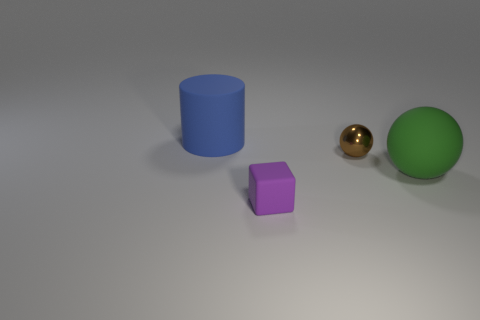What might be the purpose of arranging these objects in this manner? This arrangement of objects could be created for various purposes, such as a simple demonstrative 3D composition highlighting different geometric shapes and colors, or it could be part of a visual experiment in a computer graphics test scene to showcase rendering techniques and lighting effects. 